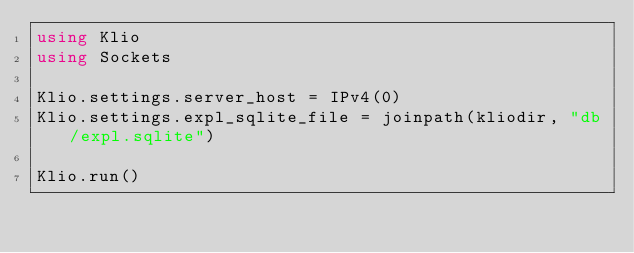<code> <loc_0><loc_0><loc_500><loc_500><_Julia_>using Klio
using Sockets

Klio.settings.server_host = IPv4(0)
Klio.settings.expl_sqlite_file = joinpath(kliodir, "db/expl.sqlite")

Klio.run()
</code> 